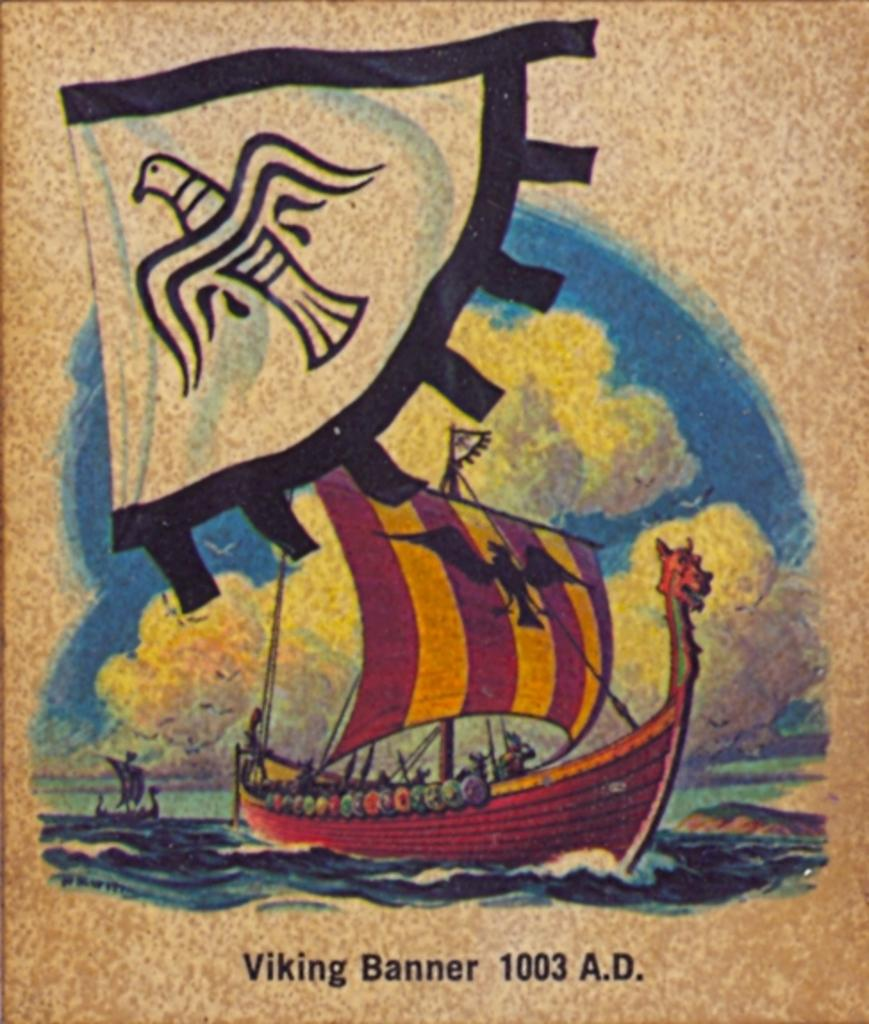<image>
Write a terse but informative summary of the picture. A picture of a boat is labeled with the year 1003 A.D. 